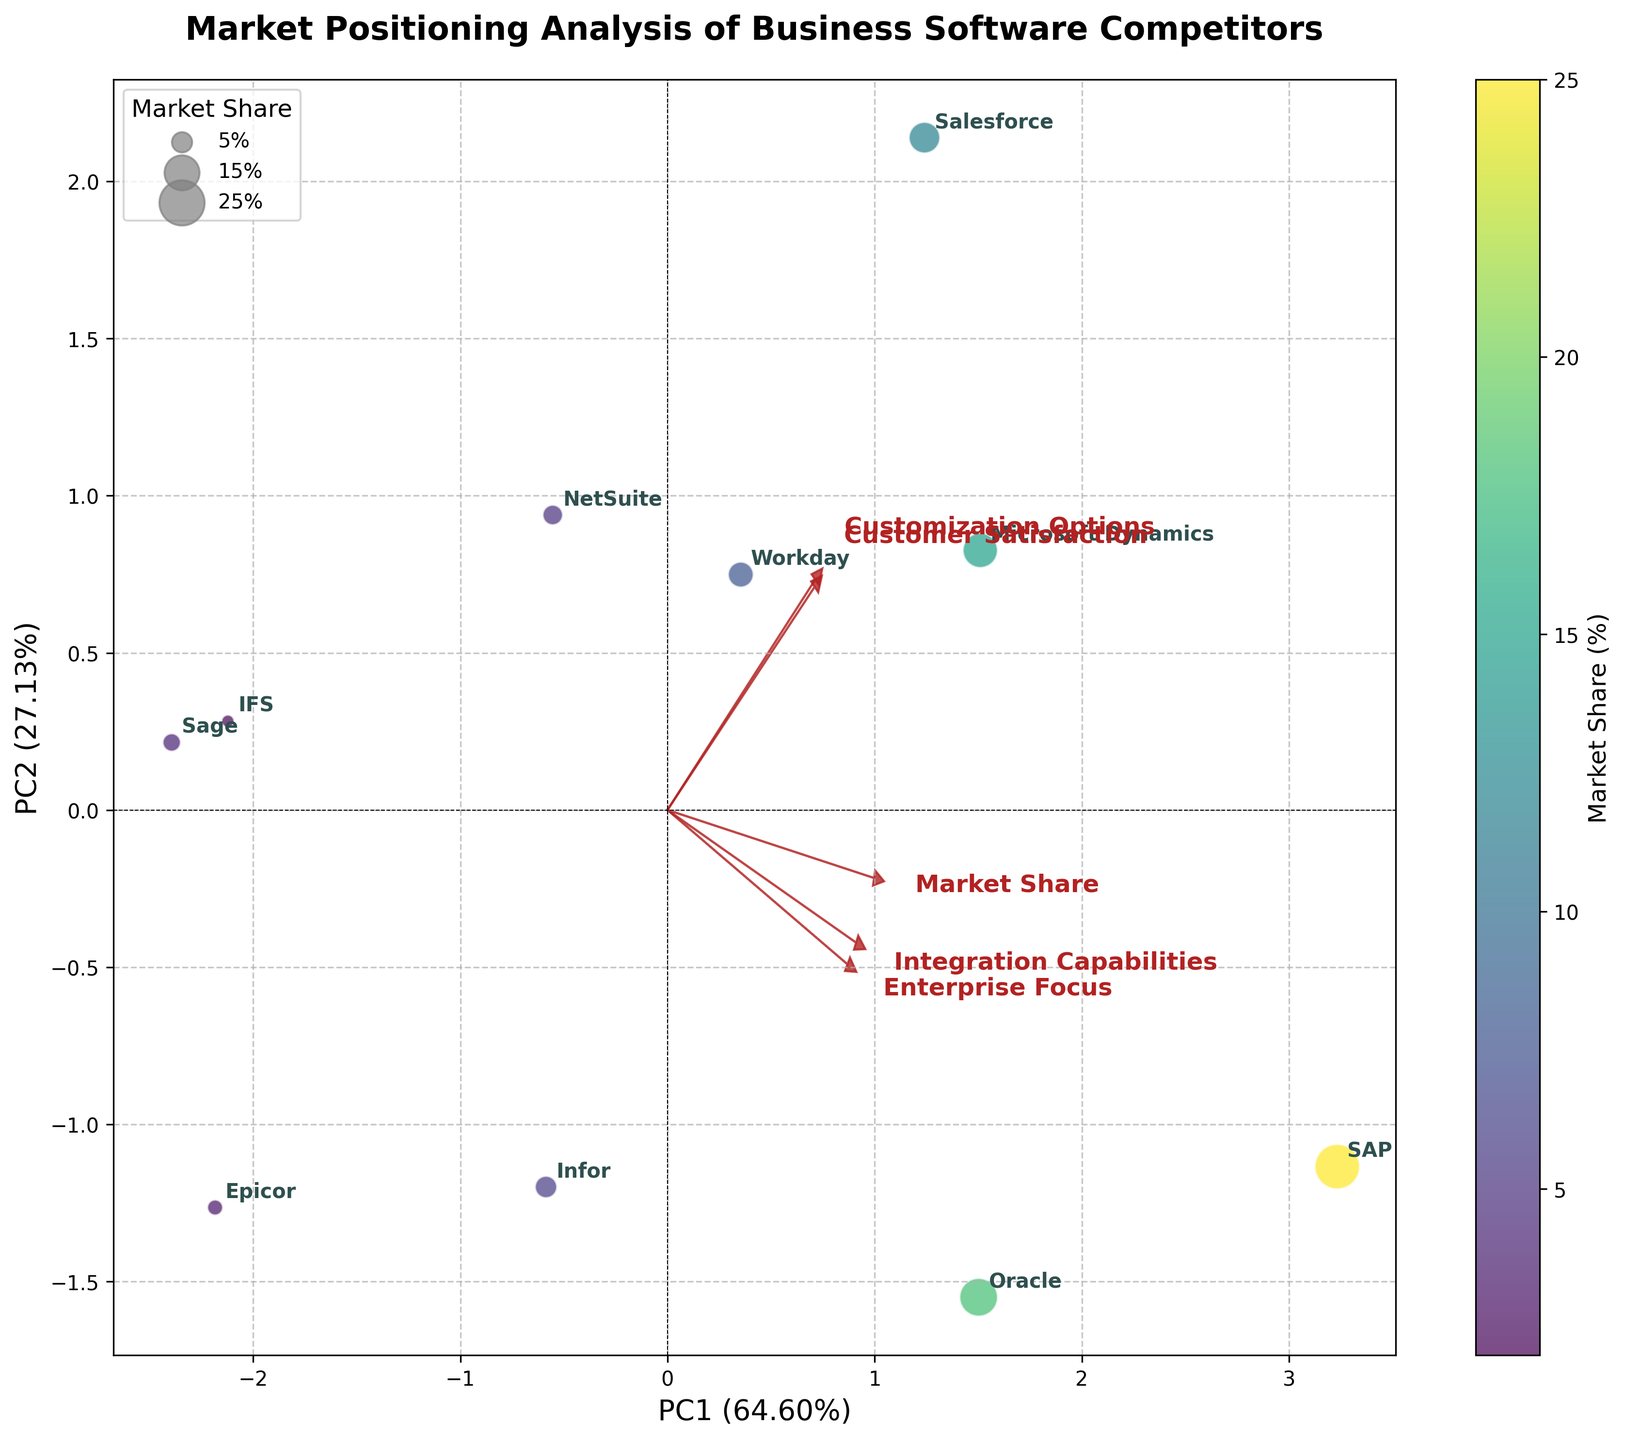Which company has the highest market share? The figure shows circles with different sizes proportional to the market share. You can identify the largest circle to determine the company with the highest market share.
Answer: SAP Which company has the smallest market share? The figure shows circles with different sizes proportional to the market share. You can identify the smallest circle to determine the company with the smallest market share.
Answer: IFS What is the title of the figure? The title is displayed at the top of the figure.
Answer: Market Positioning Analysis of Business Software Competitors How are the companies differentiated by color in the scatter plot? Companies are differentiated by color using a gradient, where the color intensity correlates with market share. The color bar to the side of the plot indicates this.
Answer: By market share Which feature has the greatest influence on the first principal component (PC1)? The direction and length of the arrows representing the features determine their influence on the principal components. Find the arrow that aligns most with the PC1 axis.
Answer: Market Share Which two companies are closest in terms of their principal components? By looking at the scatter plot, compare the positions of data points to identify the two that are closest to each other.
Answer: Oracle and IFS How are the vectors (arrows) labeled on the biplot? The vectors are labeled with the feature names they represent, located at the ends of the arrows.
Answer: With feature names Which company has the highest customer satisfaction? By examining the scatter plot and the labels of companies, find the company that aligns closest with the Customer Satisfaction vector's direction.
Answer: Salesforce Which features are positively correlated with integration capabilities? In a biplot, features that point in a similar direction are positively correlated. Check the orientation of the Integration Capabilities vector relative to others.
Answer: Enterprise Focus, Customer Satisfaction, Customization Options How much variance is explained by the first two principal components? The explained variance percentages are typically provided in the axis labels of a PCA biplot. Sum up the percentages provided for PC1 and PC2.
Answer: 100% 